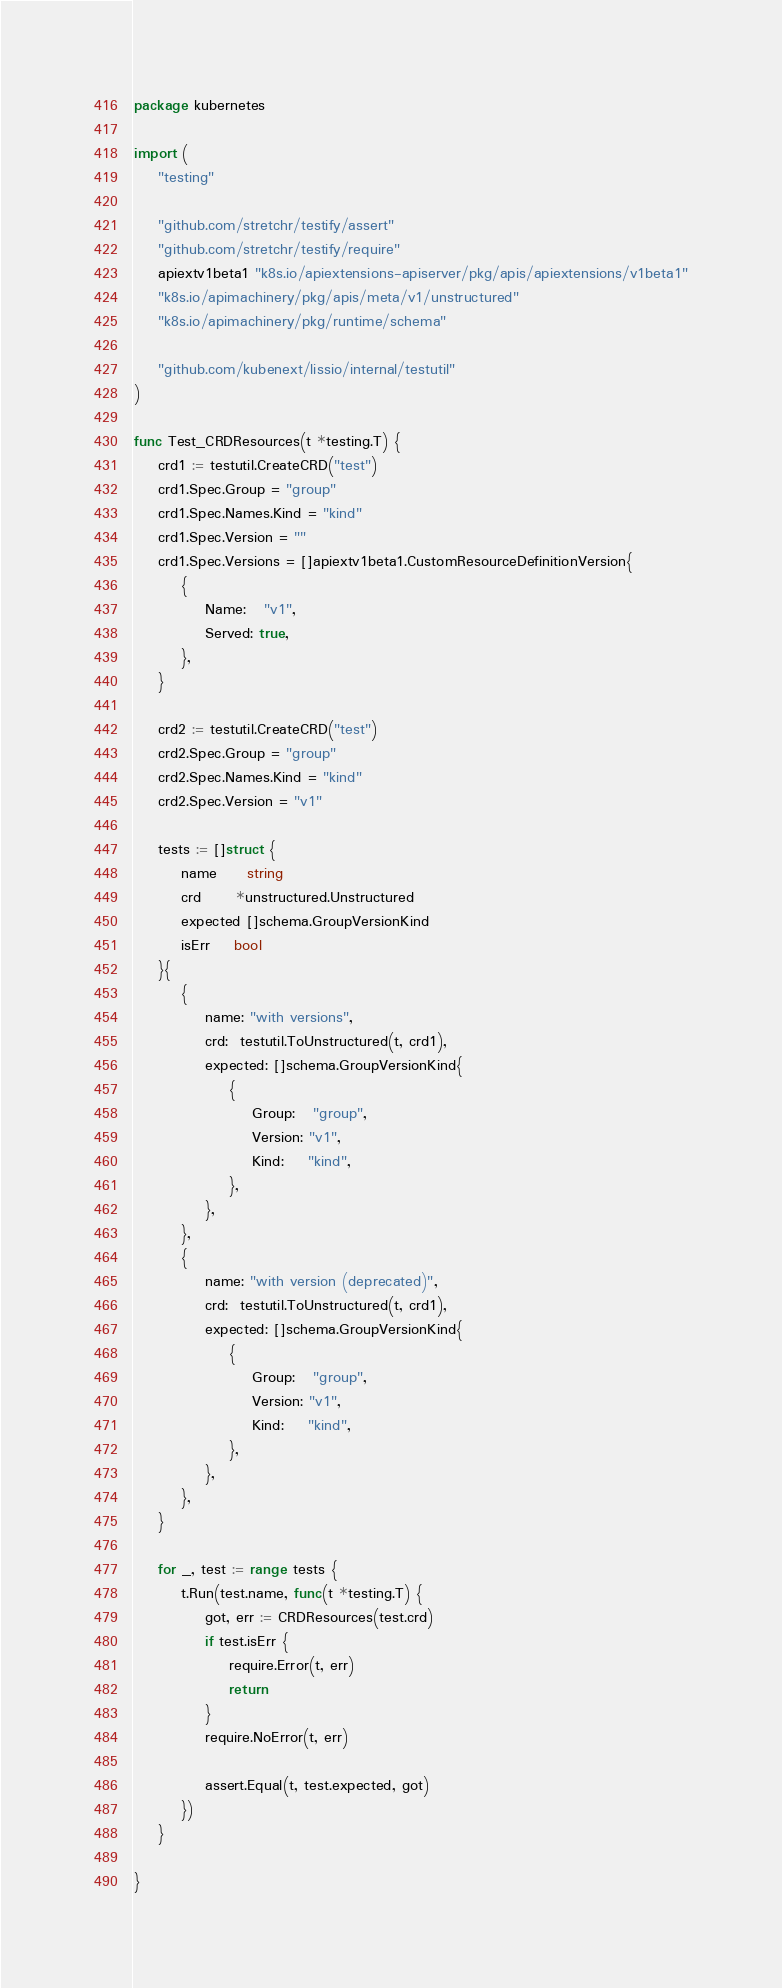<code> <loc_0><loc_0><loc_500><loc_500><_Go_>package kubernetes

import (
	"testing"

	"github.com/stretchr/testify/assert"
	"github.com/stretchr/testify/require"
	apiextv1beta1 "k8s.io/apiextensions-apiserver/pkg/apis/apiextensions/v1beta1"
	"k8s.io/apimachinery/pkg/apis/meta/v1/unstructured"
	"k8s.io/apimachinery/pkg/runtime/schema"

	"github.com/kubenext/lissio/internal/testutil"
)

func Test_CRDResources(t *testing.T) {
	crd1 := testutil.CreateCRD("test")
	crd1.Spec.Group = "group"
	crd1.Spec.Names.Kind = "kind"
	crd1.Spec.Version = ""
	crd1.Spec.Versions = []apiextv1beta1.CustomResourceDefinitionVersion{
		{
			Name:   "v1",
			Served: true,
		},
	}

	crd2 := testutil.CreateCRD("test")
	crd2.Spec.Group = "group"
	crd2.Spec.Names.Kind = "kind"
	crd2.Spec.Version = "v1"

	tests := []struct {
		name     string
		crd      *unstructured.Unstructured
		expected []schema.GroupVersionKind
		isErr    bool
	}{
		{
			name: "with versions",
			crd:  testutil.ToUnstructured(t, crd1),
			expected: []schema.GroupVersionKind{
				{
					Group:   "group",
					Version: "v1",
					Kind:    "kind",
				},
			},
		},
		{
			name: "with version (deprecated)",
			crd:  testutil.ToUnstructured(t, crd1),
			expected: []schema.GroupVersionKind{
				{
					Group:   "group",
					Version: "v1",
					Kind:    "kind",
				},
			},
		},
	}

	for _, test := range tests {
		t.Run(test.name, func(t *testing.T) {
			got, err := CRDResources(test.crd)
			if test.isErr {
				require.Error(t, err)
				return
			}
			require.NoError(t, err)

			assert.Equal(t, test.expected, got)
		})
	}

}
</code> 